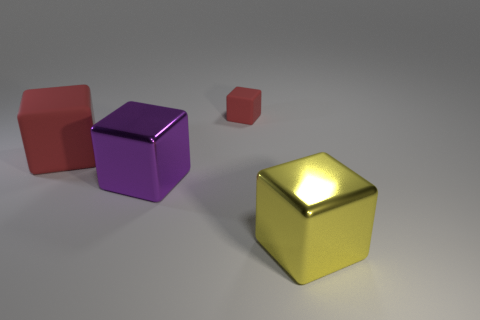Add 3 purple cubes. How many objects exist? 7 Subtract all big purple cubes. How many cubes are left? 3 Subtract 1 cubes. How many cubes are left? 3 Subtract all red blocks. How many blocks are left? 2 Subtract all yellow blocks. Subtract all red balls. How many blocks are left? 3 Subtract all green balls. How many purple cubes are left? 1 Subtract all red things. Subtract all large shiny blocks. How many objects are left? 0 Add 2 large red blocks. How many large red blocks are left? 3 Add 4 yellow rubber spheres. How many yellow rubber spheres exist? 4 Subtract 0 yellow spheres. How many objects are left? 4 